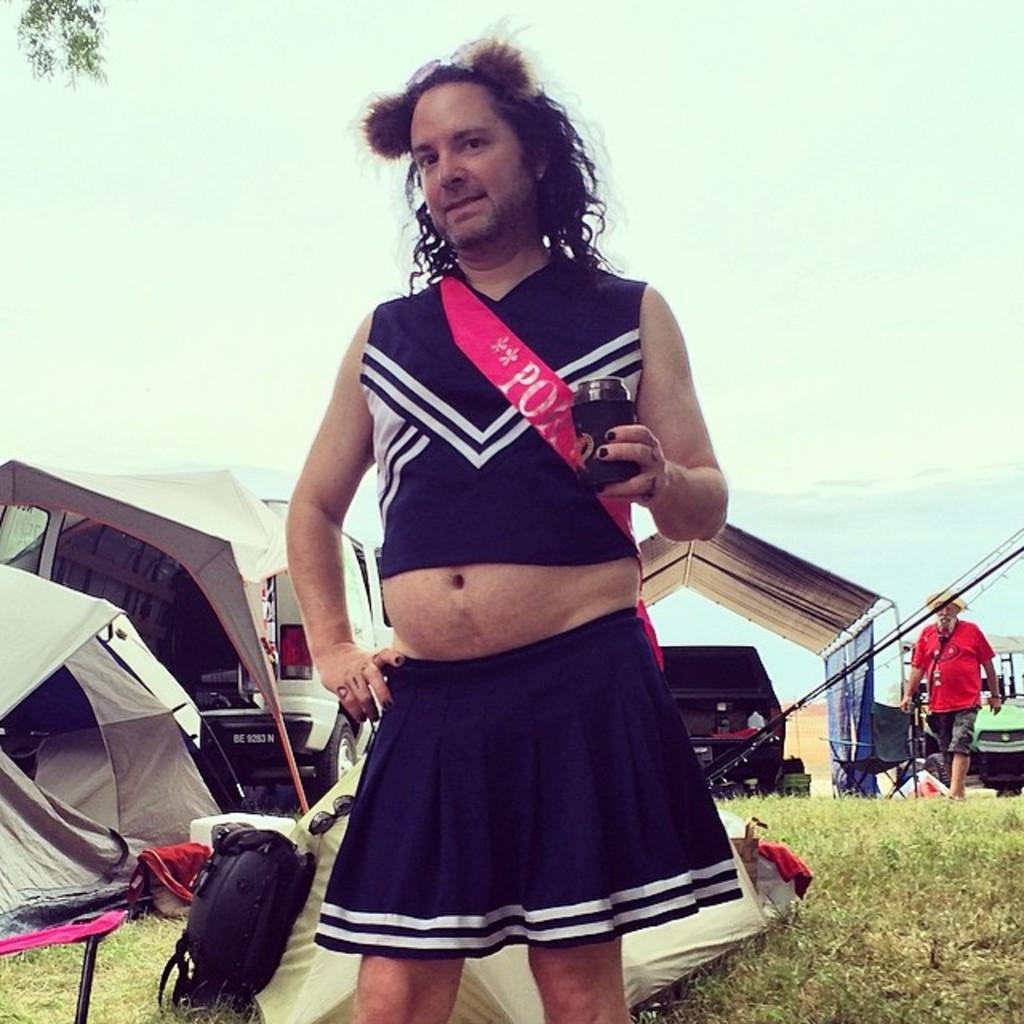<image>
Write a terse but informative summary of the picture. A man in a cheerleader's outfit wearing a sash that says PO-something. 